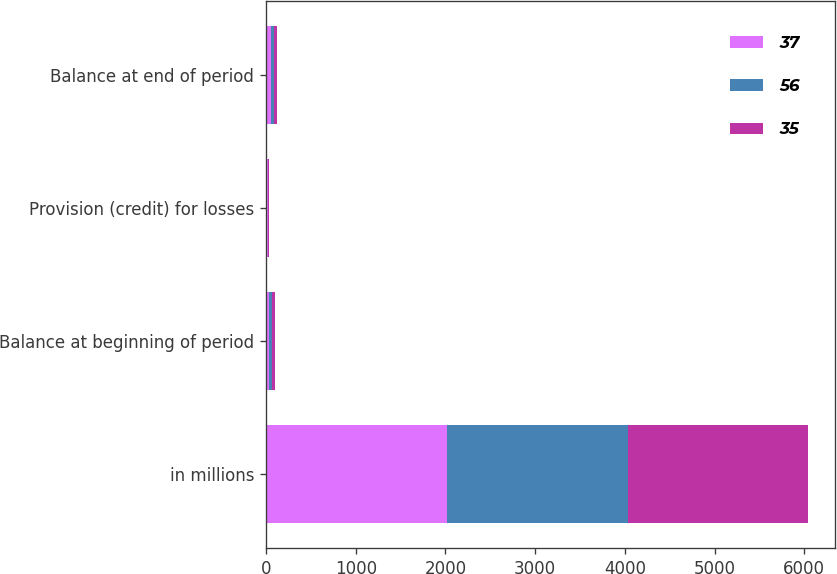Convert chart to OTSL. <chart><loc_0><loc_0><loc_500><loc_500><stacked_bar_chart><ecel><fcel>in millions<fcel>Balance at beginning of period<fcel>Provision (credit) for losses<fcel>Balance at end of period<nl><fcel>37<fcel>2015<fcel>35<fcel>21<fcel>56<nl><fcel>56<fcel>2014<fcel>37<fcel>2<fcel>35<nl><fcel>35<fcel>2013<fcel>29<fcel>8<fcel>37<nl></chart> 